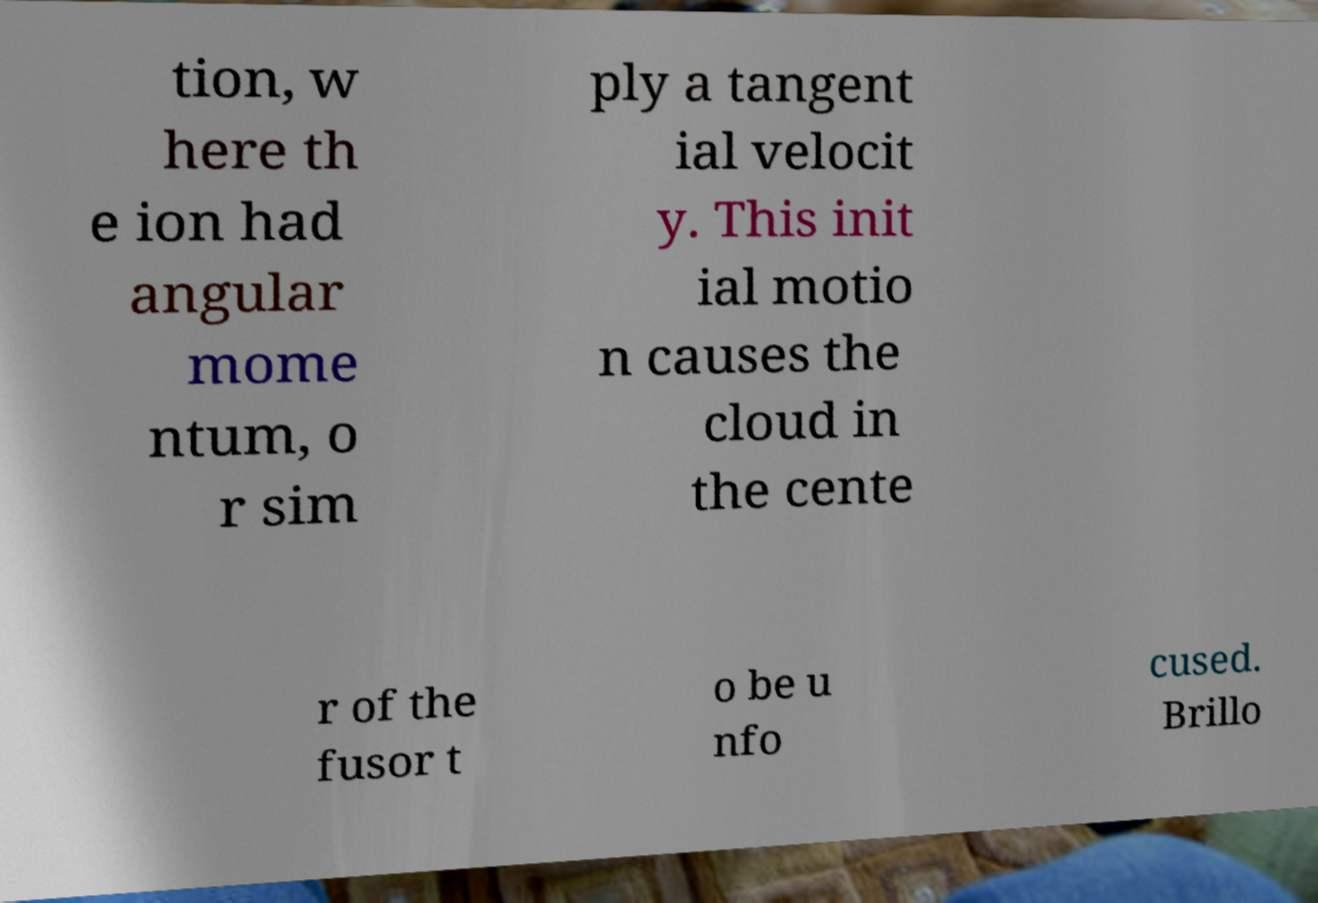Please identify and transcribe the text found in this image. tion, w here th e ion had angular mome ntum, o r sim ply a tangent ial velocit y. This init ial motio n causes the cloud in the cente r of the fusor t o be u nfo cused. Brillo 